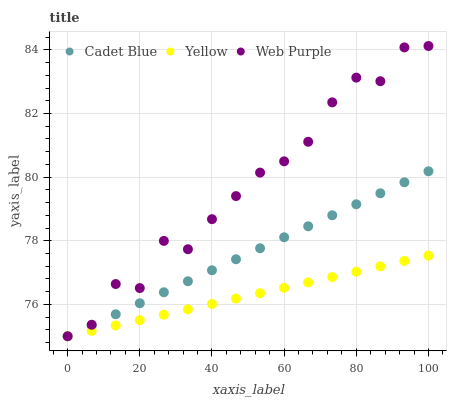Does Yellow have the minimum area under the curve?
Answer yes or no. Yes. Does Web Purple have the maximum area under the curve?
Answer yes or no. Yes. Does Cadet Blue have the minimum area under the curve?
Answer yes or no. No. Does Cadet Blue have the maximum area under the curve?
Answer yes or no. No. Is Cadet Blue the smoothest?
Answer yes or no. Yes. Is Web Purple the roughest?
Answer yes or no. Yes. Is Yellow the smoothest?
Answer yes or no. No. Is Yellow the roughest?
Answer yes or no. No. Does Web Purple have the lowest value?
Answer yes or no. Yes. Does Web Purple have the highest value?
Answer yes or no. Yes. Does Cadet Blue have the highest value?
Answer yes or no. No. Does Web Purple intersect Cadet Blue?
Answer yes or no. Yes. Is Web Purple less than Cadet Blue?
Answer yes or no. No. Is Web Purple greater than Cadet Blue?
Answer yes or no. No. 